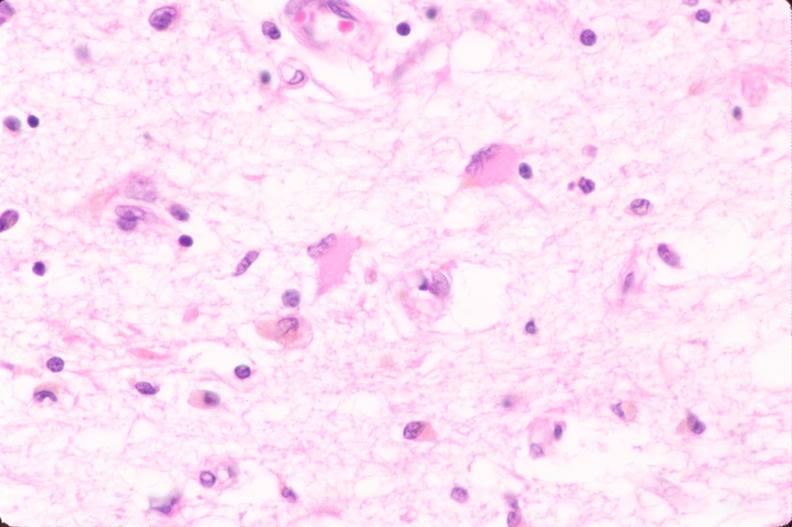what is present?
Answer the question using a single word or phrase. Respiratory 